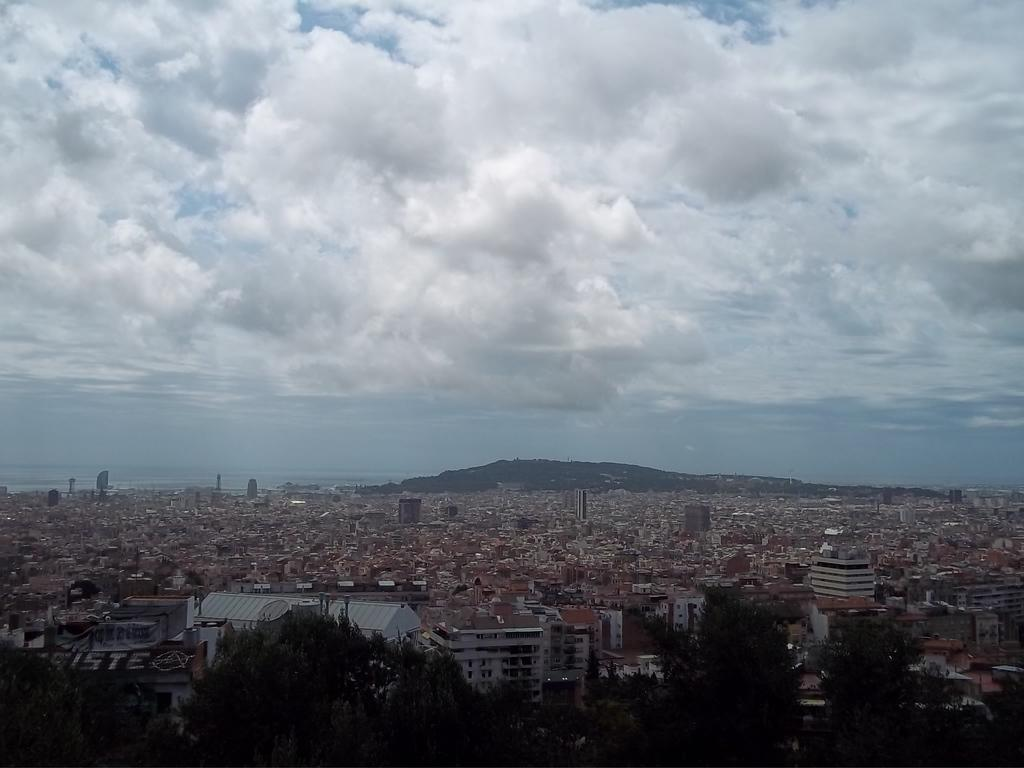What type of natural environment is depicted in the image? There are many trees in the image, indicating a natural environment. What type of man-made structures are present in the image? There are buildings in the image. What can be seen in the background of the image? Water and the sky are visible in the background of the image. What is the condition of the sky in the image? Clouds are present in the sky. Can you tell me how many chess pieces are on the rod in the image? There is no rod or chess pieces present in the image. 